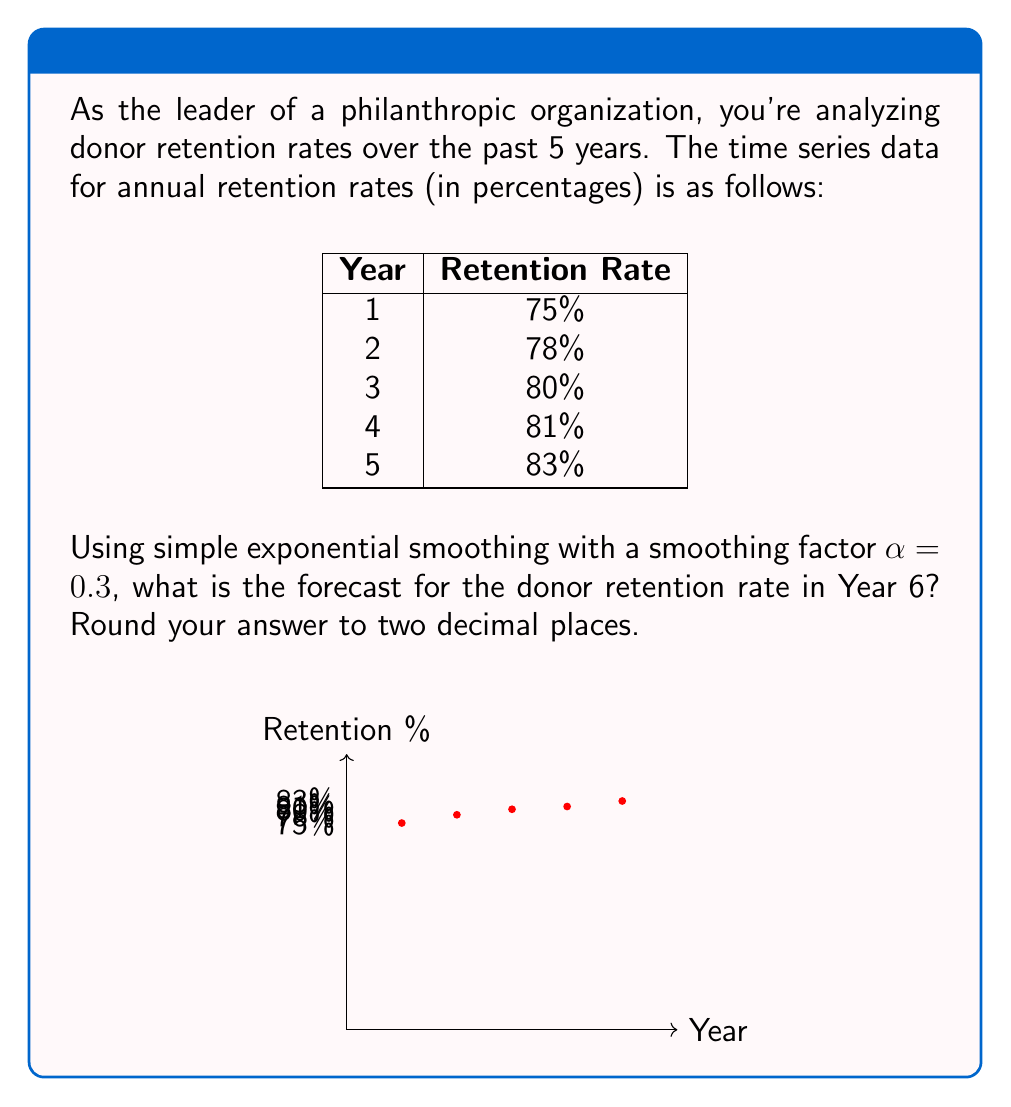What is the answer to this math problem? To forecast the donor retention rate for Year 6 using simple exponential smoothing, we'll follow these steps:

1) The formula for simple exponential smoothing is:
   $$F_{t+1} = \alpha Y_t + (1-\alpha)F_t$$
   where $F_{t+1}$ is the forecast for the next period, $Y_t$ is the actual value at time $t$, $F_t$ is the forecast for the current period, and $\alpha$ is the smoothing factor.

2) We start with the initial forecast $F_1$ equal to the first observation:
   $F_1 = 75\%$

3) Now we calculate the forecasts for each year:

   For Year 2:
   $F_2 = 0.3(75\%) + 0.7(75\%) = 75\%$

   For Year 3:
   $F_3 = 0.3(78\%) + 0.7(75\%) = 75.9\%$

   For Year 4:
   $F_4 = 0.3(80\%) + 0.7(75.9\%) = 77.13\%$

   For Year 5:
   $F_5 = 0.3(81\%) + 0.7(77.13\%) = 78.291\%$

4) Finally, we calculate the forecast for Year 6:
   $F_6 = 0.3(83\%) + 0.7(78.291\%) = 79.7037\%$

5) Rounding to two decimal places, we get 79.70%.
Answer: 79.70% 